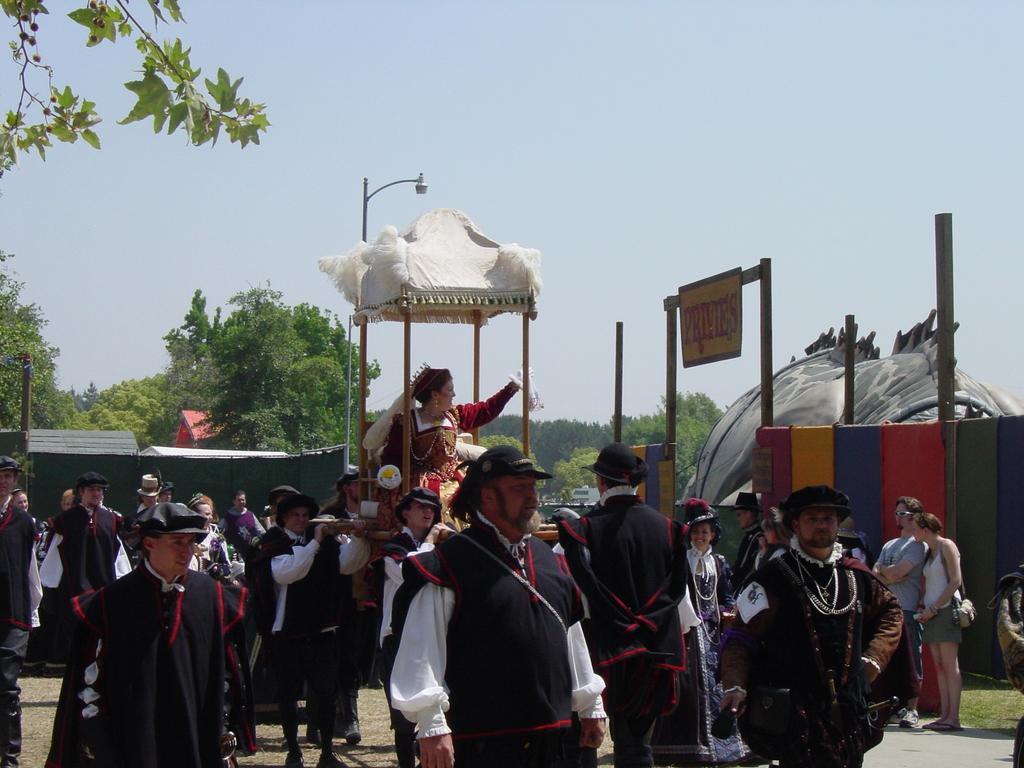Describe this image in one or two sentences. In this image, we can see a group of people. Few are standing and walking. In the middle of the image, we can see a woman is sitting. Background we can see so many trees, poles, wall, name board and sky. 